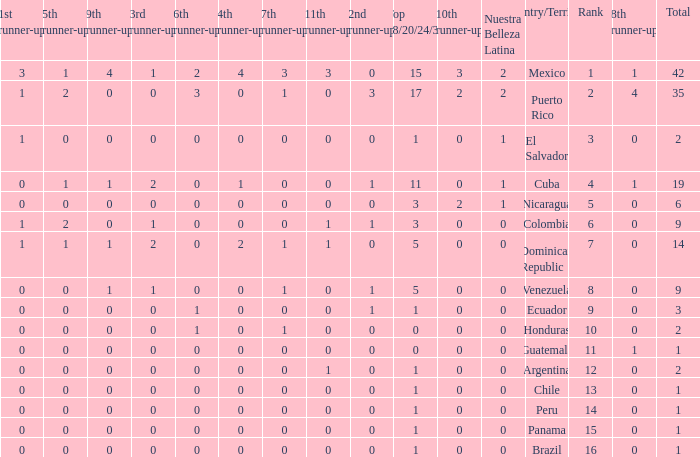What is the average total of the country with a 4th runner-up of 0 and a Nuestra Bellaza Latina less than 0? None. 